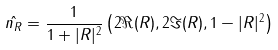<formula> <loc_0><loc_0><loc_500><loc_500>\hat { n _ { R } } = \frac { 1 } { 1 + | R | ^ { 2 } } \left ( 2 \Re ( R ) , 2 \Im ( R ) , 1 - | R | ^ { 2 } \right )</formula> 